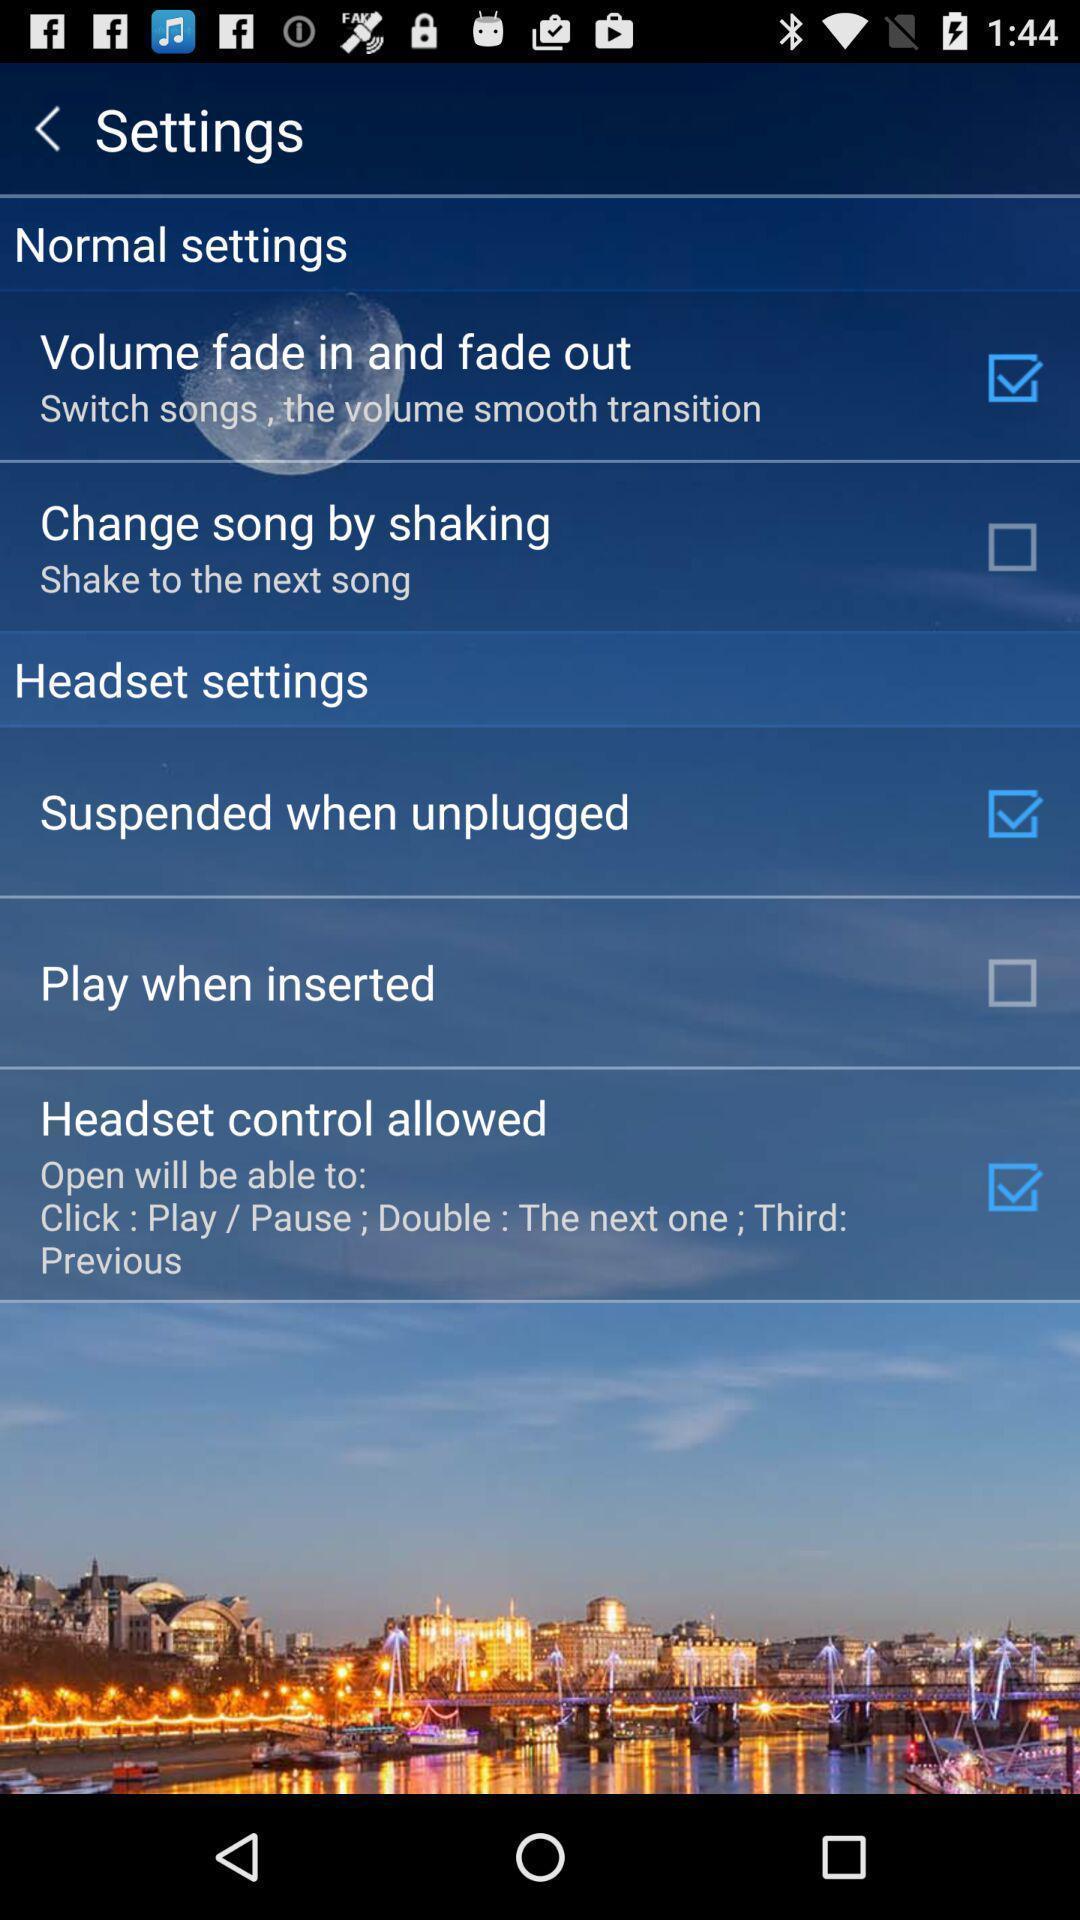Provide a textual representation of this image. Settings page. 